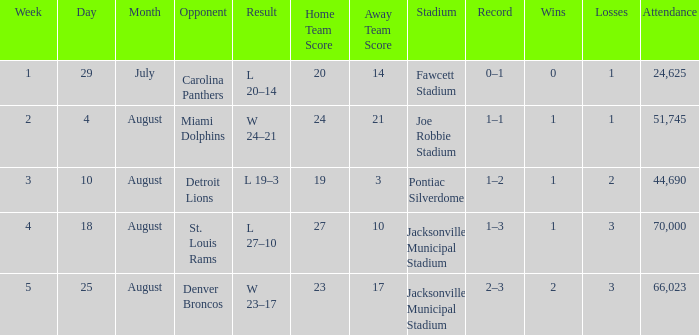WHEN has a Opponent of miami dolphins? August 4. 